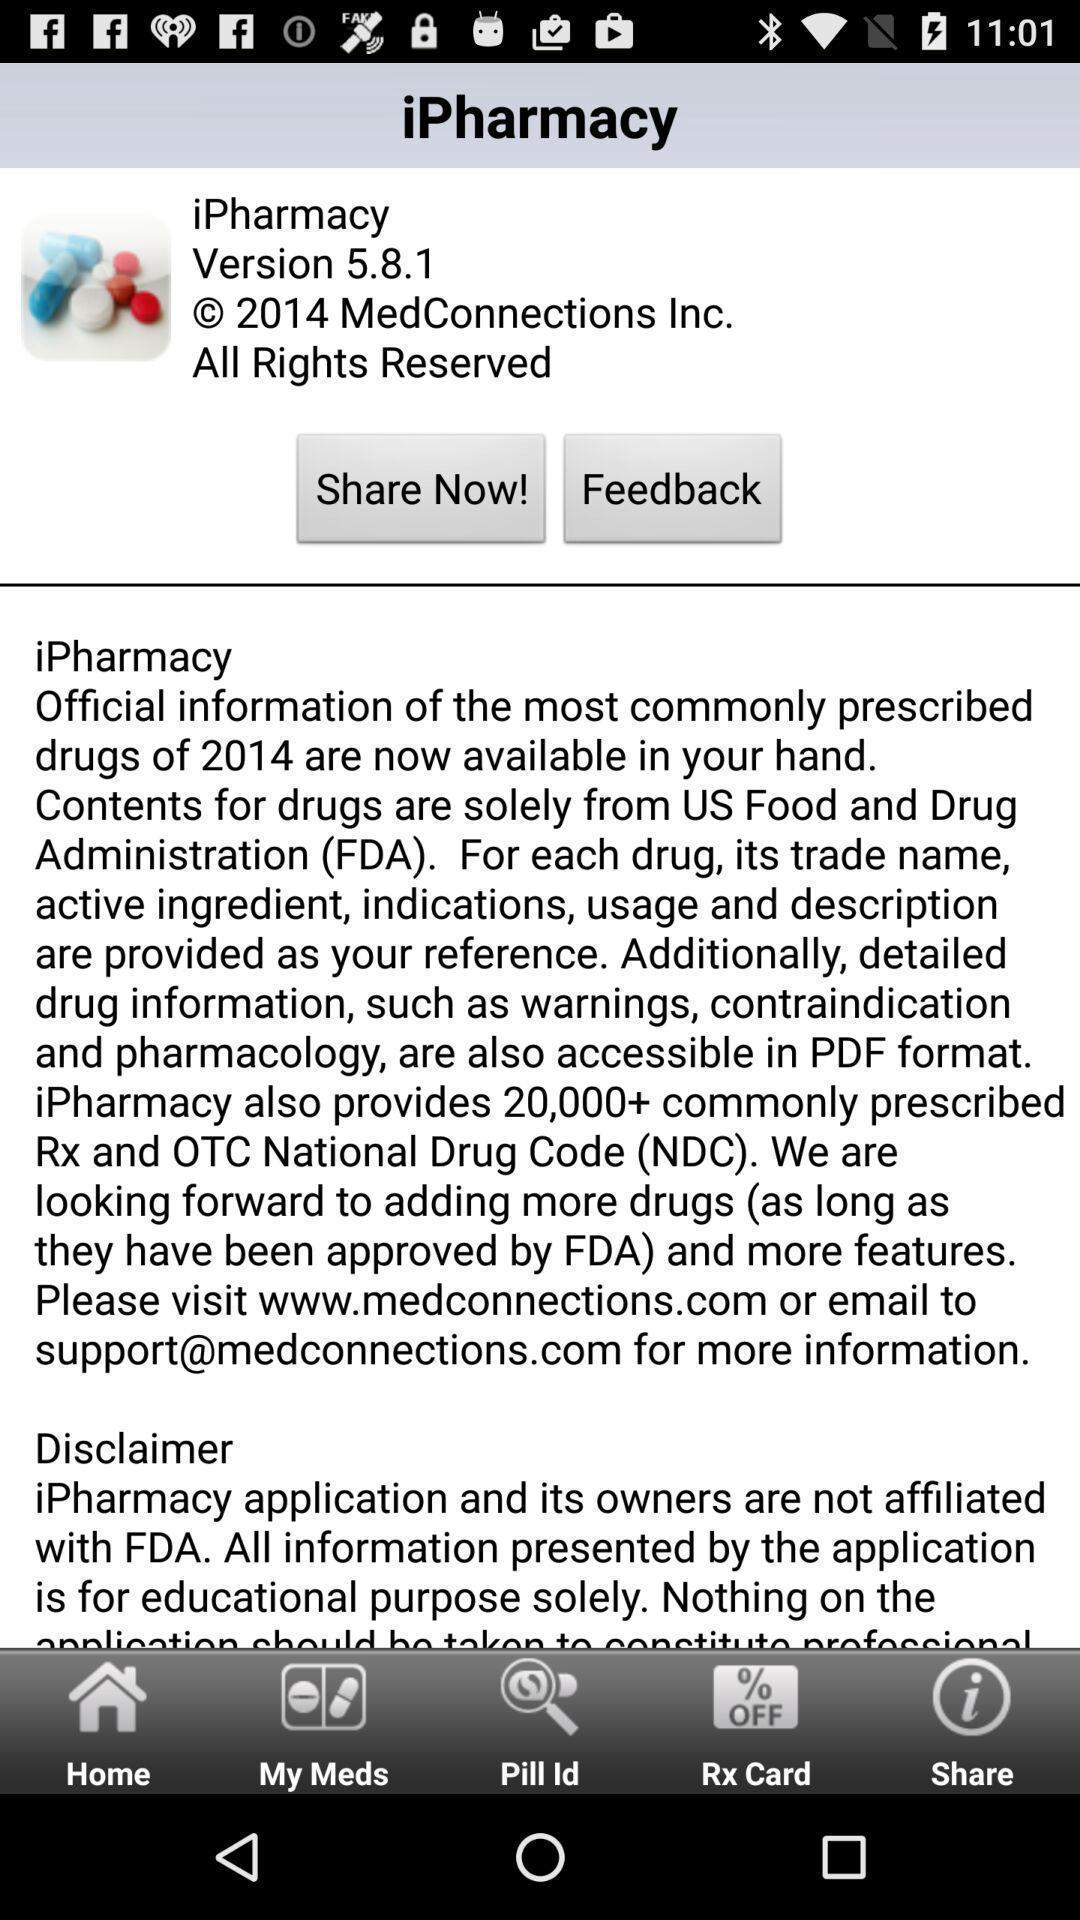Summarize the main components in this picture. Screen shows version details in a medical app. 